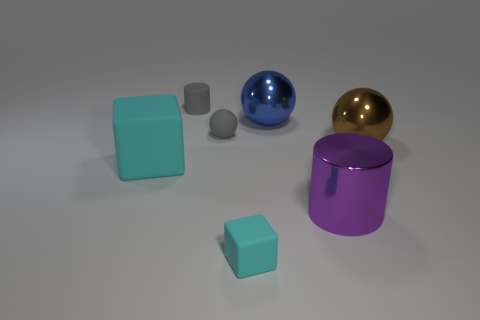The blue metal object is what size?
Offer a terse response. Large. What is the material of the small cyan cube?
Provide a succinct answer. Rubber. Is the size of the cyan thing that is in front of the purple cylinder the same as the small matte ball?
Ensure brevity in your answer.  Yes. What number of things are either gray balls or big yellow metal objects?
Offer a terse response. 1. There is a rubber object that is the same color as the large block; what is its shape?
Provide a short and direct response. Cube. There is a shiny thing that is on the left side of the big brown thing and behind the large cyan thing; what size is it?
Your answer should be very brief. Large. What number of tiny yellow metal cylinders are there?
Keep it short and to the point. 0. How many blocks are either tiny cyan rubber things or small matte things?
Offer a terse response. 1. There is a blue ball right of the cyan block that is behind the purple thing; how many brown objects are to the right of it?
Your answer should be compact. 1. The cylinder that is the same size as the blue metal ball is what color?
Provide a short and direct response. Purple. 